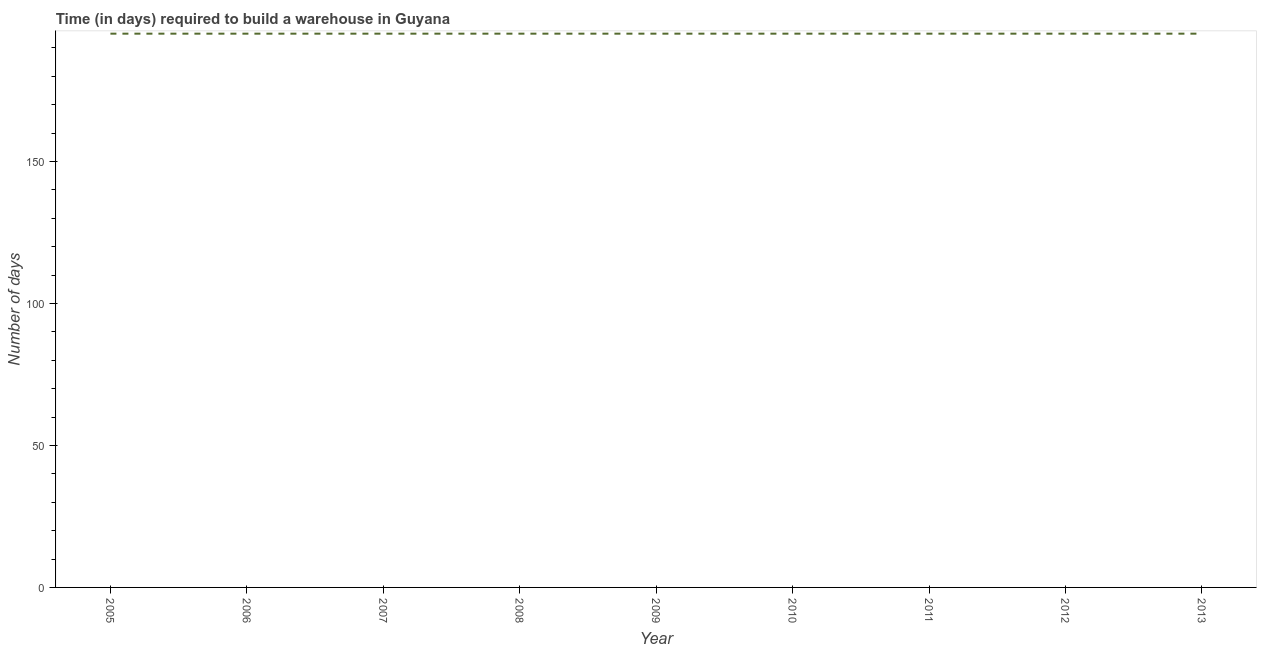What is the time required to build a warehouse in 2010?
Ensure brevity in your answer.  195. Across all years, what is the maximum time required to build a warehouse?
Your answer should be very brief. 195. Across all years, what is the minimum time required to build a warehouse?
Make the answer very short. 195. In which year was the time required to build a warehouse maximum?
Keep it short and to the point. 2005. In which year was the time required to build a warehouse minimum?
Provide a succinct answer. 2005. What is the sum of the time required to build a warehouse?
Provide a succinct answer. 1755. What is the average time required to build a warehouse per year?
Keep it short and to the point. 195. What is the median time required to build a warehouse?
Provide a succinct answer. 195. In how many years, is the time required to build a warehouse greater than 100 days?
Provide a short and direct response. 9. Do a majority of the years between 2006 and 2007 (inclusive) have time required to build a warehouse greater than 70 days?
Ensure brevity in your answer.  Yes. What is the ratio of the time required to build a warehouse in 2007 to that in 2013?
Offer a terse response. 1. Is the time required to build a warehouse in 2006 less than that in 2007?
Provide a succinct answer. No. Is the difference between the time required to build a warehouse in 2005 and 2011 greater than the difference between any two years?
Provide a short and direct response. Yes. What is the difference between the highest and the second highest time required to build a warehouse?
Offer a terse response. 0. Is the sum of the time required to build a warehouse in 2010 and 2013 greater than the maximum time required to build a warehouse across all years?
Offer a very short reply. Yes. In how many years, is the time required to build a warehouse greater than the average time required to build a warehouse taken over all years?
Make the answer very short. 0. How many lines are there?
Provide a short and direct response. 1. How many years are there in the graph?
Keep it short and to the point. 9. What is the difference between two consecutive major ticks on the Y-axis?
Provide a succinct answer. 50. Does the graph contain any zero values?
Make the answer very short. No. What is the title of the graph?
Provide a succinct answer. Time (in days) required to build a warehouse in Guyana. What is the label or title of the Y-axis?
Offer a terse response. Number of days. What is the Number of days in 2005?
Offer a terse response. 195. What is the Number of days of 2006?
Give a very brief answer. 195. What is the Number of days in 2007?
Your answer should be compact. 195. What is the Number of days of 2008?
Provide a short and direct response. 195. What is the Number of days in 2009?
Give a very brief answer. 195. What is the Number of days of 2010?
Ensure brevity in your answer.  195. What is the Number of days of 2011?
Keep it short and to the point. 195. What is the Number of days of 2012?
Your answer should be compact. 195. What is the Number of days in 2013?
Provide a succinct answer. 195. What is the difference between the Number of days in 2005 and 2006?
Your response must be concise. 0. What is the difference between the Number of days in 2005 and 2009?
Make the answer very short. 0. What is the difference between the Number of days in 2005 and 2011?
Your response must be concise. 0. What is the difference between the Number of days in 2005 and 2013?
Your response must be concise. 0. What is the difference between the Number of days in 2006 and 2008?
Offer a very short reply. 0. What is the difference between the Number of days in 2006 and 2009?
Make the answer very short. 0. What is the difference between the Number of days in 2006 and 2010?
Your answer should be compact. 0. What is the difference between the Number of days in 2006 and 2011?
Keep it short and to the point. 0. What is the difference between the Number of days in 2006 and 2013?
Your response must be concise. 0. What is the difference between the Number of days in 2007 and 2009?
Provide a short and direct response. 0. What is the difference between the Number of days in 2007 and 2010?
Make the answer very short. 0. What is the difference between the Number of days in 2007 and 2011?
Offer a terse response. 0. What is the difference between the Number of days in 2007 and 2013?
Give a very brief answer. 0. What is the difference between the Number of days in 2008 and 2013?
Your response must be concise. 0. What is the difference between the Number of days in 2009 and 2010?
Keep it short and to the point. 0. What is the difference between the Number of days in 2009 and 2011?
Provide a short and direct response. 0. What is the difference between the Number of days in 2009 and 2013?
Give a very brief answer. 0. What is the difference between the Number of days in 2010 and 2011?
Offer a terse response. 0. What is the difference between the Number of days in 2010 and 2012?
Ensure brevity in your answer.  0. What is the difference between the Number of days in 2010 and 2013?
Ensure brevity in your answer.  0. What is the difference between the Number of days in 2011 and 2013?
Provide a short and direct response. 0. What is the ratio of the Number of days in 2005 to that in 2006?
Your answer should be very brief. 1. What is the ratio of the Number of days in 2005 to that in 2013?
Your response must be concise. 1. What is the ratio of the Number of days in 2006 to that in 2008?
Provide a succinct answer. 1. What is the ratio of the Number of days in 2006 to that in 2010?
Give a very brief answer. 1. What is the ratio of the Number of days in 2006 to that in 2011?
Make the answer very short. 1. What is the ratio of the Number of days in 2007 to that in 2008?
Offer a terse response. 1. What is the ratio of the Number of days in 2007 to that in 2009?
Offer a very short reply. 1. What is the ratio of the Number of days in 2007 to that in 2010?
Keep it short and to the point. 1. What is the ratio of the Number of days in 2007 to that in 2011?
Offer a very short reply. 1. What is the ratio of the Number of days in 2007 to that in 2012?
Provide a short and direct response. 1. What is the ratio of the Number of days in 2007 to that in 2013?
Ensure brevity in your answer.  1. What is the ratio of the Number of days in 2008 to that in 2010?
Make the answer very short. 1. What is the ratio of the Number of days in 2008 to that in 2011?
Keep it short and to the point. 1. What is the ratio of the Number of days in 2008 to that in 2012?
Your answer should be compact. 1. What is the ratio of the Number of days in 2009 to that in 2010?
Make the answer very short. 1. What is the ratio of the Number of days in 2009 to that in 2012?
Provide a succinct answer. 1. What is the ratio of the Number of days in 2009 to that in 2013?
Provide a succinct answer. 1. What is the ratio of the Number of days in 2011 to that in 2012?
Offer a terse response. 1. What is the ratio of the Number of days in 2011 to that in 2013?
Your answer should be very brief. 1. 